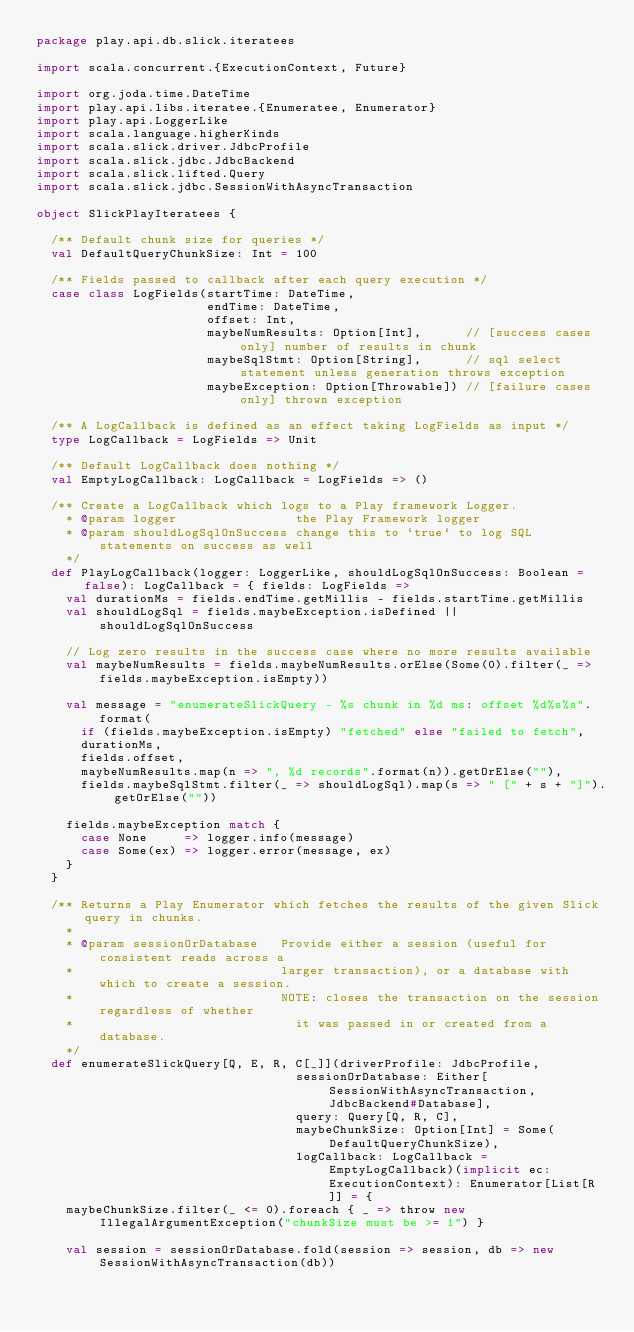Convert code to text. <code><loc_0><loc_0><loc_500><loc_500><_Scala_>package play.api.db.slick.iteratees

import scala.concurrent.{ExecutionContext, Future}

import org.joda.time.DateTime
import play.api.libs.iteratee.{Enumeratee, Enumerator}
import play.api.LoggerLike
import scala.language.higherKinds
import scala.slick.driver.JdbcProfile
import scala.slick.jdbc.JdbcBackend
import scala.slick.lifted.Query
import scala.slick.jdbc.SessionWithAsyncTransaction

object SlickPlayIteratees {

  /** Default chunk size for queries */
  val DefaultQueryChunkSize: Int = 100

  /** Fields passed to callback after each query execution */
  case class LogFields(startTime: DateTime,
                       endTime: DateTime,
                       offset: Int,
                       maybeNumResults: Option[Int],      // [success cases only] number of results in chunk
                       maybeSqlStmt: Option[String],      // sql select statement unless generation throws exception
                       maybeException: Option[Throwable]) // [failure cases only] thrown exception

  /** A LogCallback is defined as an effect taking LogFields as input */
  type LogCallback = LogFields => Unit

  /** Default LogCallback does nothing */
  val EmptyLogCallback: LogCallback = LogFields => ()

  /** Create a LogCallback which logs to a Play framework Logger.
    * @param logger                the Play Framework logger
    * @param shouldLogSqlOnSuccess change this to `true` to log SQL statements on success as well
    */
  def PlayLogCallback(logger: LoggerLike, shouldLogSqlOnSuccess: Boolean = false): LogCallback = { fields: LogFields =>
    val durationMs = fields.endTime.getMillis - fields.startTime.getMillis
    val shouldLogSql = fields.maybeException.isDefined || shouldLogSqlOnSuccess

    // Log zero results in the success case where no more results available
    val maybeNumResults = fields.maybeNumResults.orElse(Some(0).filter(_ => fields.maybeException.isEmpty))

    val message = "enumerateSlickQuery - %s chunk in %d ms: offset %d%s%s".format(
      if (fields.maybeException.isEmpty) "fetched" else "failed to fetch",
      durationMs,
      fields.offset,
      maybeNumResults.map(n => ", %d records".format(n)).getOrElse(""),
      fields.maybeSqlStmt.filter(_ => shouldLogSql).map(s => " [" + s + "]").getOrElse(""))

    fields.maybeException match {
      case None     => logger.info(message)
      case Some(ex) => logger.error(message, ex)
    }
  }

  /** Returns a Play Enumerator which fetches the results of the given Slick query in chunks.
    *
    * @param sessionOrDatabase   Provide either a session (useful for consistent reads across a
    *                            larger transaction), or a database with which to create a session.
    *                            NOTE: closes the transaction on the session regardless of whether
    *                              it was passed in or created from a database.
    */
  def enumerateSlickQuery[Q, E, R, C[_]](driverProfile: JdbcProfile,
                                   sessionOrDatabase: Either[SessionWithAsyncTransaction, JdbcBackend#Database],
                                   query: Query[Q, R, C],
                                   maybeChunkSize: Option[Int] = Some(DefaultQueryChunkSize),
                                   logCallback: LogCallback = EmptyLogCallback)(implicit ec: ExecutionContext): Enumerator[List[R]] = {
    maybeChunkSize.filter(_ <= 0).foreach { _ => throw new IllegalArgumentException("chunkSize must be >= 1") }

    val session = sessionOrDatabase.fold(session => session, db => new SessionWithAsyncTransaction(db))</code> 